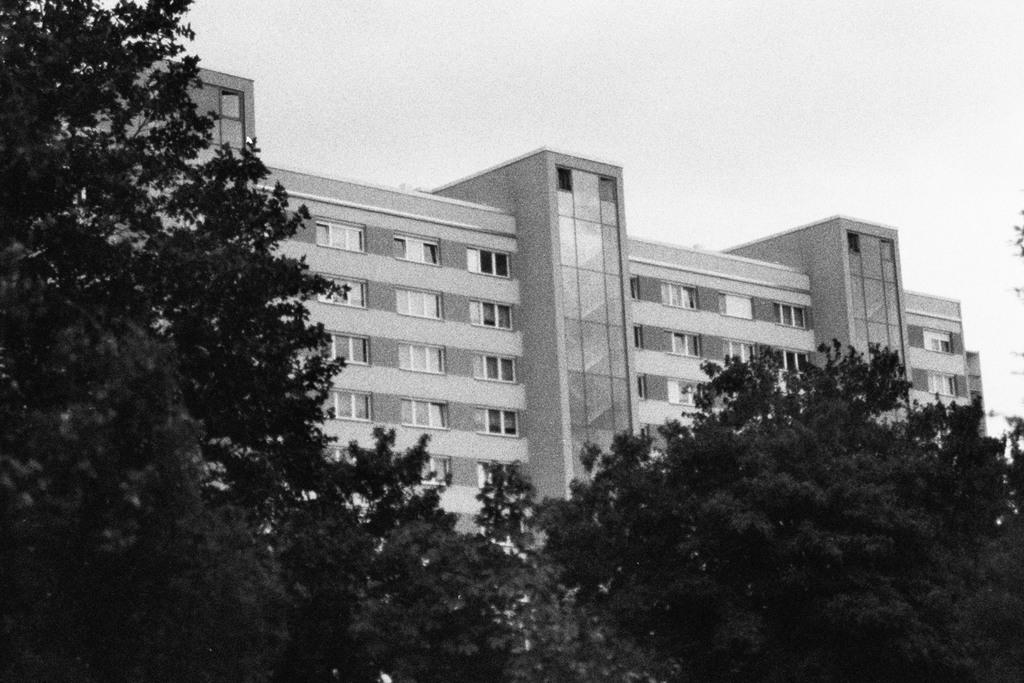What is the color scheme of the image? The image is black and white. What can be seen in the background of the image? There are buildings, trees, and the sky visible in the background of the image. Are there any boats visible in the image? There are no boats present in the image. What type of vacation destination is depicted in the image? The image does not depict a vacation destination; it features a black and white scene with buildings, trees, and the sky in the background. 